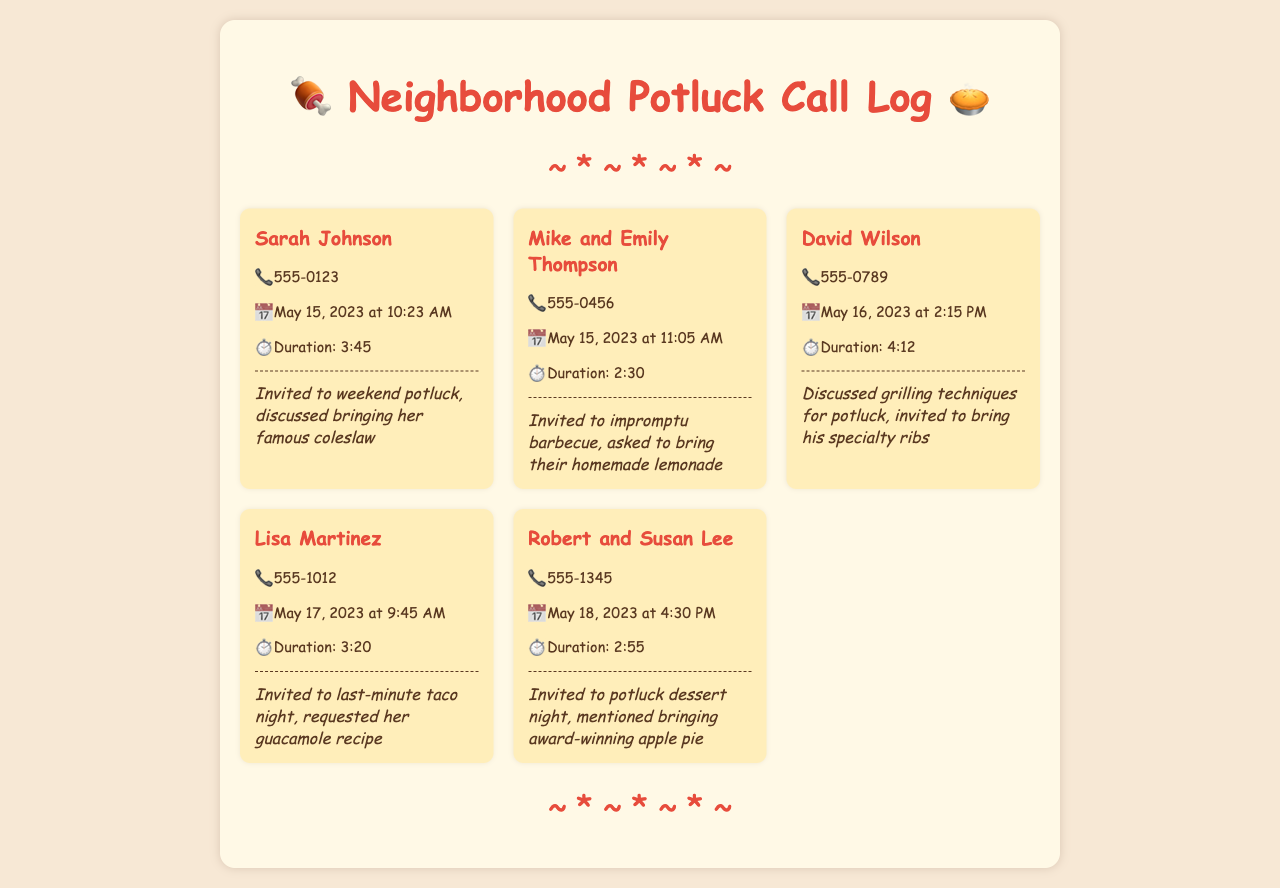What is the name of the first person invited to a potluck? The first entry in the call log shows Sarah Johnson, who was invited to a weekend potluck.
Answer: Sarah Johnson What date did Mike and Emily Thompson receive their invitation? The call log indicates Mike and Emily were invited on May 15, 2023.
Answer: May 15, 2023 What was discussed during the call with David Wilson? The note mentions grilling techniques were discussed, along with inviting him to bring his specialty ribs.
Answer: Grilling techniques How long was the call with Lisa Martinez? The call duration for Lisa Martinez's conversation is given as 3:20.
Answer: 3:20 Which neighbor was invited to bring homemade lemonade? The call log specifies that Mike and Emily Thompson were asked to bring homemade lemonade.
Answer: Mike and Emily Thompson What type of event was Robert and Susan Lee invited to? The invitation for Robert and Susan Lee was for a potluck dessert night.
Answer: Potluck dessert night How many calls were made on May 17, 2023? According to the log, one call was made on that date, specifically to Lisa Martinez.
Answer: One What was the duration of David Wilson's call? The call log specifies that David Wilson's call lasted 4:12.
Answer: 4:12 What dish did Robert and Susan Lee plan to bring? The document notes that they mentioned bringing their award-winning apple pie.
Answer: Award-winning apple pie 